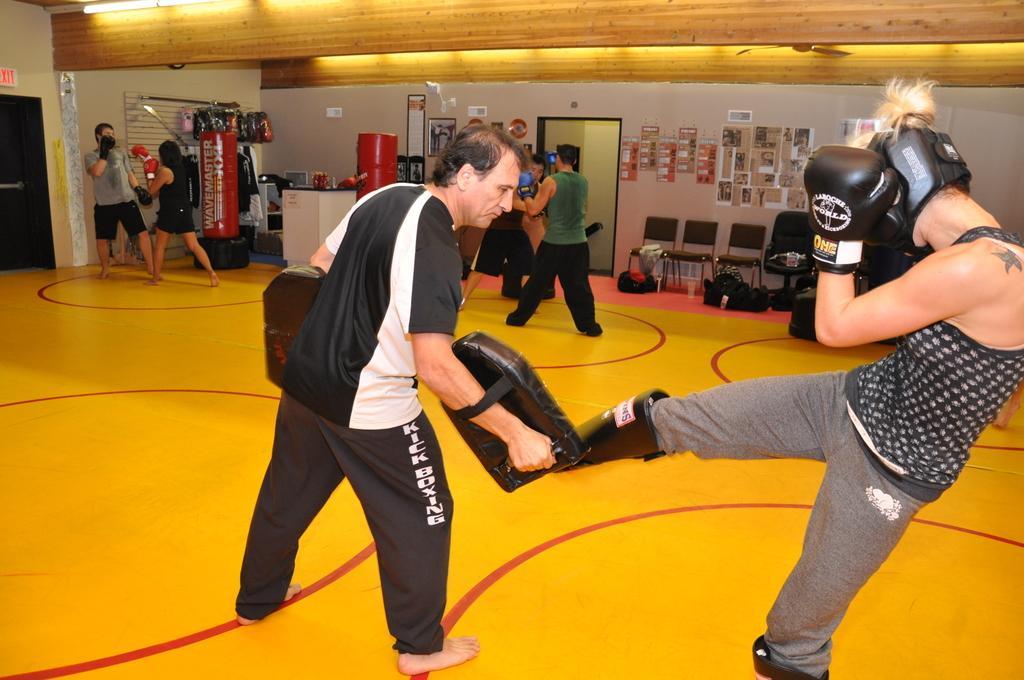Can you describe this image briefly? On the right side, there is a person in a t-shirt, giving a punch to the pad which is held by a person who is in t-shirt, standing on the floor, on which there are red color circles. In the background, there are other persons, there are posters pasted on the wall, a light attached to the roof, there are chairs arranged and there are other objects. 